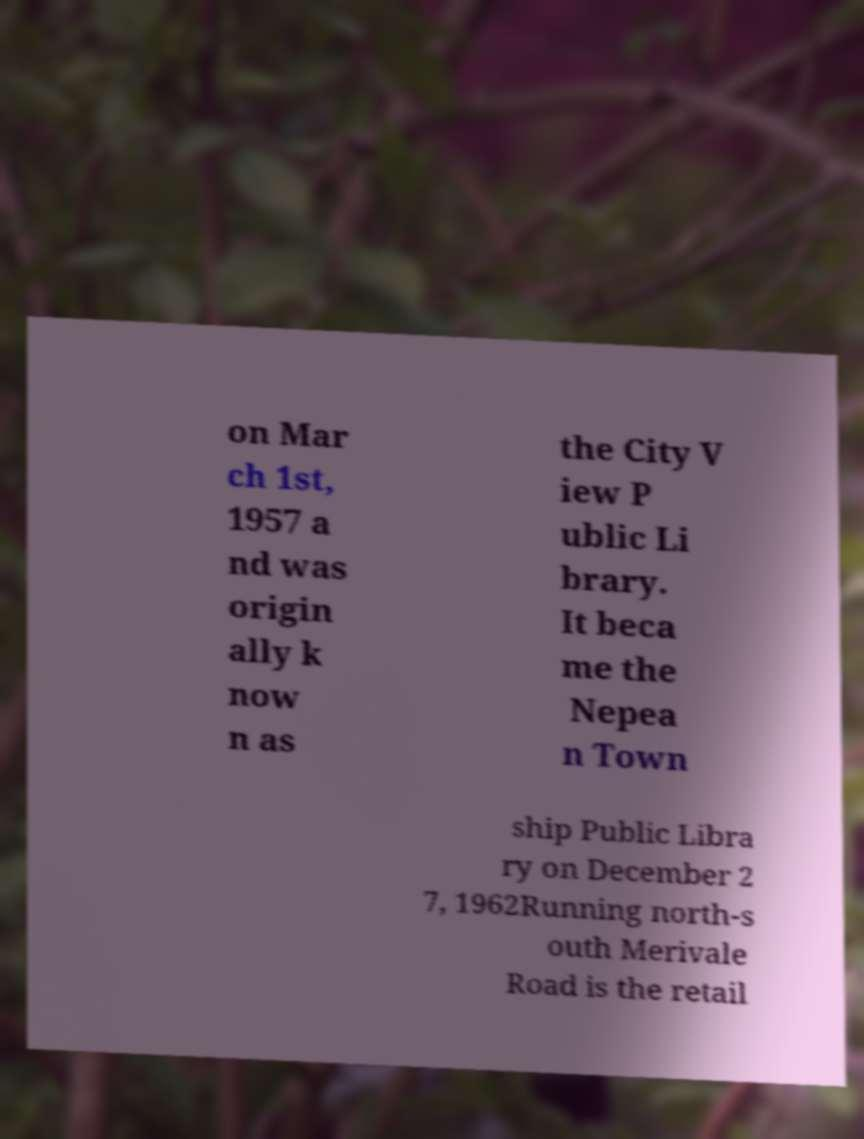Please identify and transcribe the text found in this image. on Mar ch 1st, 1957 a nd was origin ally k now n as the City V iew P ublic Li brary. It beca me the Nepea n Town ship Public Libra ry on December 2 7, 1962Running north-s outh Merivale Road is the retail 